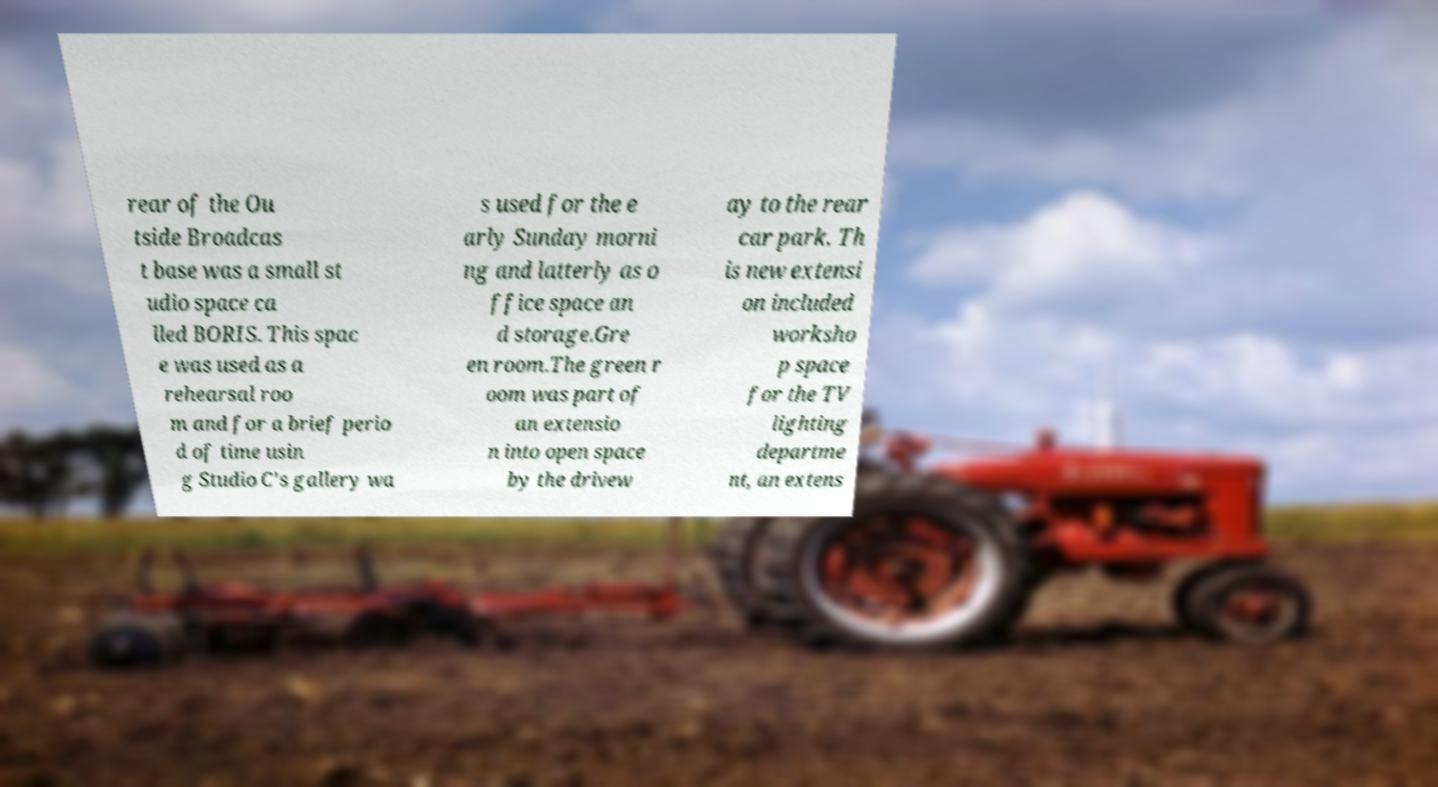Could you extract and type out the text from this image? rear of the Ou tside Broadcas t base was a small st udio space ca lled BORIS. This spac e was used as a rehearsal roo m and for a brief perio d of time usin g Studio C's gallery wa s used for the e arly Sunday morni ng and latterly as o ffice space an d storage.Gre en room.The green r oom was part of an extensio n into open space by the drivew ay to the rear car park. Th is new extensi on included worksho p space for the TV lighting departme nt, an extens 